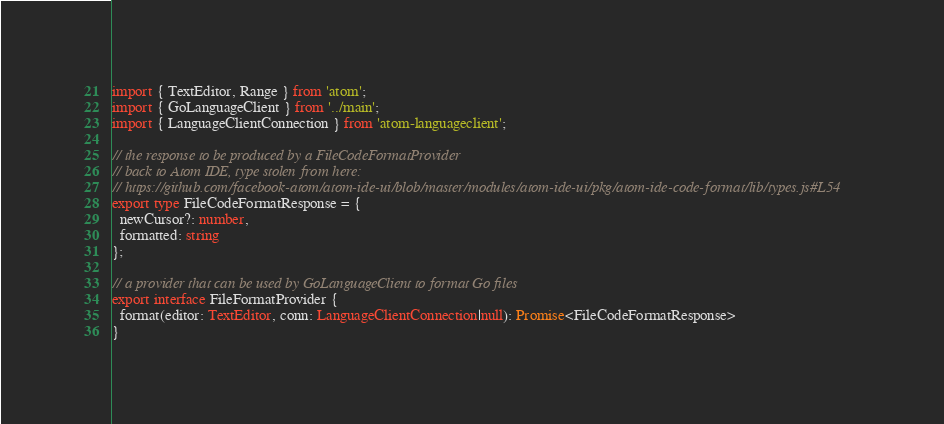Convert code to text. <code><loc_0><loc_0><loc_500><loc_500><_TypeScript_>import { TextEditor, Range } from 'atom';
import { GoLanguageClient } from '../main';
import { LanguageClientConnection } from 'atom-languageclient';

// the response to be produced by a FileCodeFormatProvider
// back to Atom IDE, type stolen from here:
// https://github.com/facebook-atom/atom-ide-ui/blob/master/modules/atom-ide-ui/pkg/atom-ide-code-format/lib/types.js#L54
export type FileCodeFormatResponse = {
  newCursor?: number,
  formatted: string
};

// a provider that can be used by GoLanguageClient to format Go files
export interface FileFormatProvider {
  format(editor: TextEditor, conn: LanguageClientConnection|null): Promise<FileCodeFormatResponse>
}
</code> 